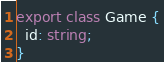Convert code to text. <code><loc_0><loc_0><loc_500><loc_500><_TypeScript_>export class Game {
  id: string;
}
</code> 